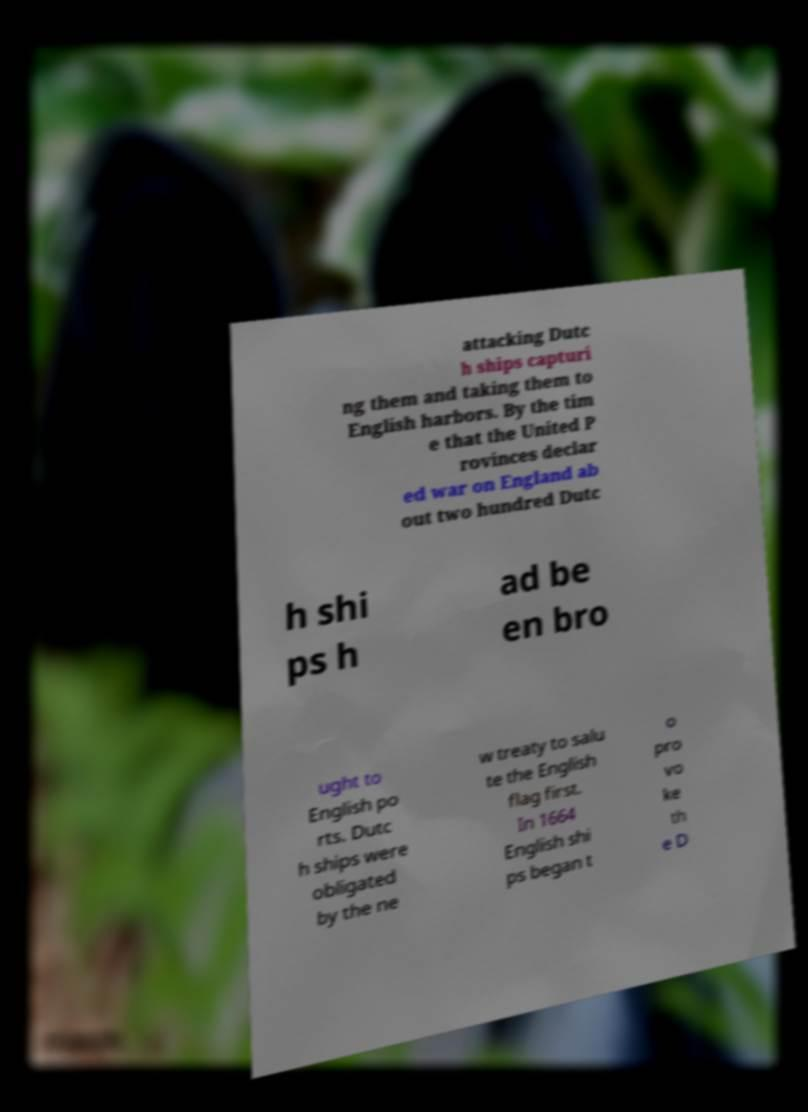Please identify and transcribe the text found in this image. attacking Dutc h ships capturi ng them and taking them to English harbors. By the tim e that the United P rovinces declar ed war on England ab out two hundred Dutc h shi ps h ad be en bro ught to English po rts. Dutc h ships were obligated by the ne w treaty to salu te the English flag first. In 1664 English shi ps began t o pro vo ke th e D 